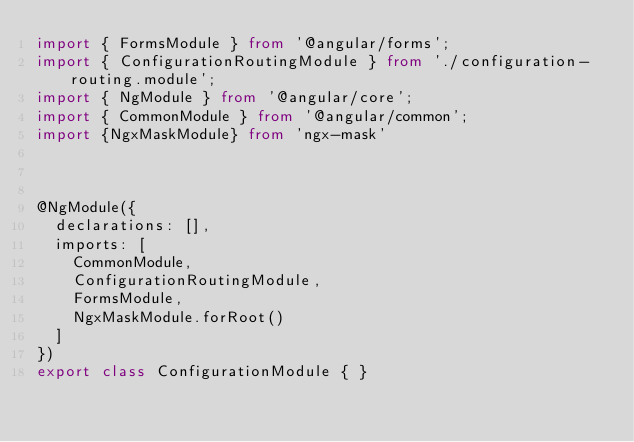<code> <loc_0><loc_0><loc_500><loc_500><_TypeScript_>import { FormsModule } from '@angular/forms';
import { ConfigurationRoutingModule } from './configuration-routing.module';
import { NgModule } from '@angular/core';
import { CommonModule } from '@angular/common';
import {NgxMaskModule} from 'ngx-mask'



@NgModule({
  declarations: [],
  imports: [
    CommonModule,
    ConfigurationRoutingModule,
    FormsModule,
    NgxMaskModule.forRoot()
  ]
})
export class ConfigurationModule { }

</code> 